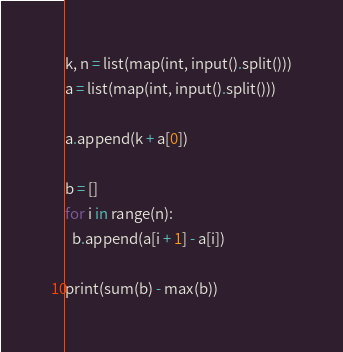<code> <loc_0><loc_0><loc_500><loc_500><_Python_>k, n = list(map(int, input().split()))
a = list(map(int, input().split()))

a.append(k + a[0])

b = []
for i in range(n):
  b.append(a[i + 1] - a[i])

print(sum(b) - max(b))
</code> 